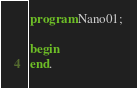Convert code to text. <code><loc_0><loc_0><loc_500><loc_500><_Pascal_>program Nano01;

begin
end.
</code> 